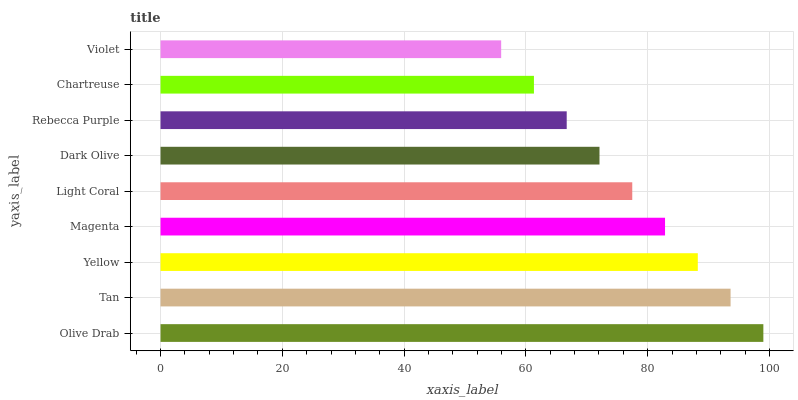Is Violet the minimum?
Answer yes or no. Yes. Is Olive Drab the maximum?
Answer yes or no. Yes. Is Tan the minimum?
Answer yes or no. No. Is Tan the maximum?
Answer yes or no. No. Is Olive Drab greater than Tan?
Answer yes or no. Yes. Is Tan less than Olive Drab?
Answer yes or no. Yes. Is Tan greater than Olive Drab?
Answer yes or no. No. Is Olive Drab less than Tan?
Answer yes or no. No. Is Light Coral the high median?
Answer yes or no. Yes. Is Light Coral the low median?
Answer yes or no. Yes. Is Yellow the high median?
Answer yes or no. No. Is Dark Olive the low median?
Answer yes or no. No. 